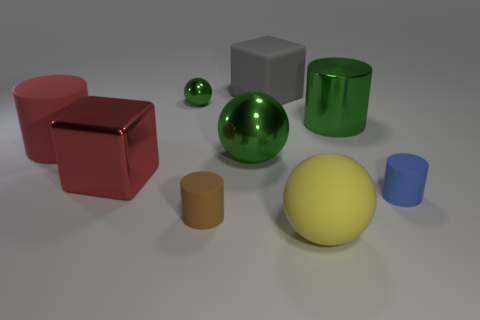What size is the other sphere that is the same color as the tiny shiny sphere?
Ensure brevity in your answer.  Large. There is a big matte object that is both on the right side of the metal cube and behind the small blue rubber cylinder; what shape is it?
Ensure brevity in your answer.  Cube. Are there an equal number of big gray cubes to the left of the tiny green shiny object and big objects that are on the right side of the small blue cylinder?
Your answer should be compact. Yes. What number of objects are either big red matte things or green balls?
Your answer should be compact. 3. What color is the rubber sphere that is the same size as the red cylinder?
Offer a terse response. Yellow. What number of things are either tiny rubber objects that are left of the blue thing or balls that are on the right side of the gray thing?
Offer a terse response. 2. Is the number of large rubber spheres that are on the right side of the large yellow ball the same as the number of small green metallic cylinders?
Offer a very short reply. Yes. Do the brown rubber cylinder in front of the large red metallic thing and the green metal object that is on the right side of the big gray object have the same size?
Your answer should be compact. No. What number of other things are the same size as the rubber block?
Offer a terse response. 5. There is a tiny matte object that is in front of the tiny thing that is right of the large shiny ball; are there any things that are behind it?
Ensure brevity in your answer.  Yes. 